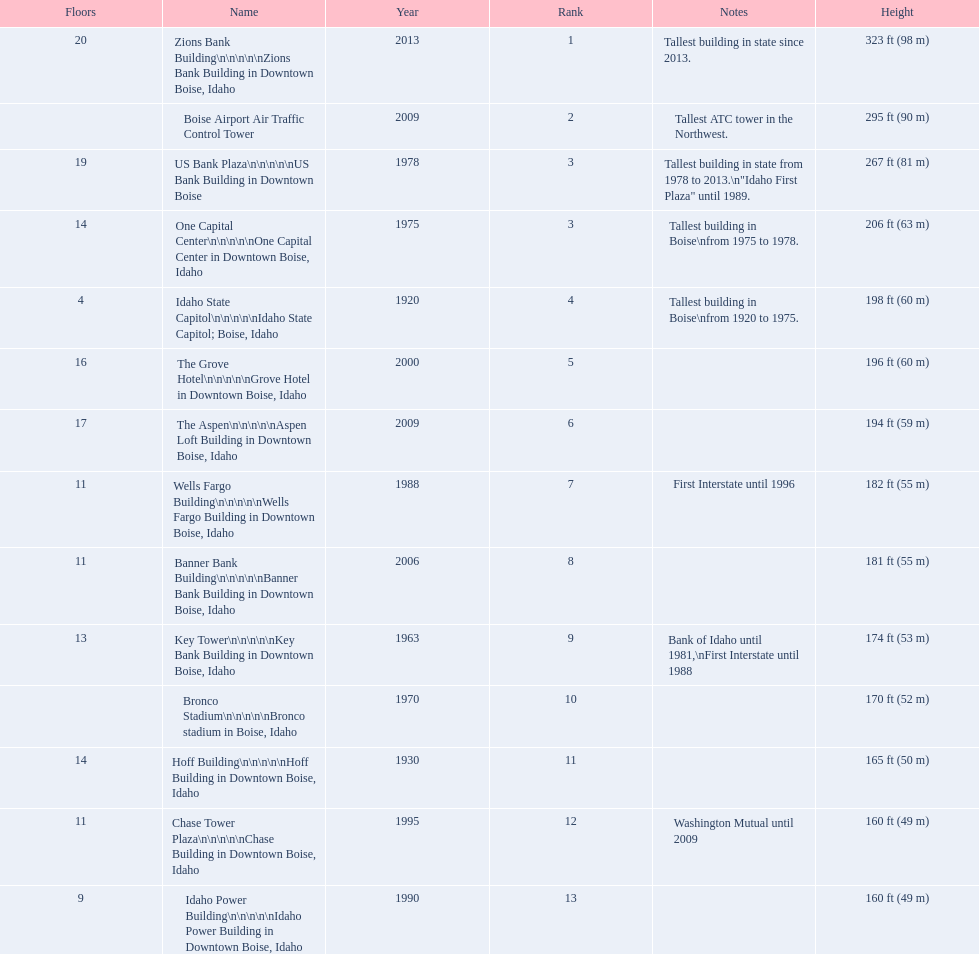How tall (in meters) is the tallest building? 98 m. 